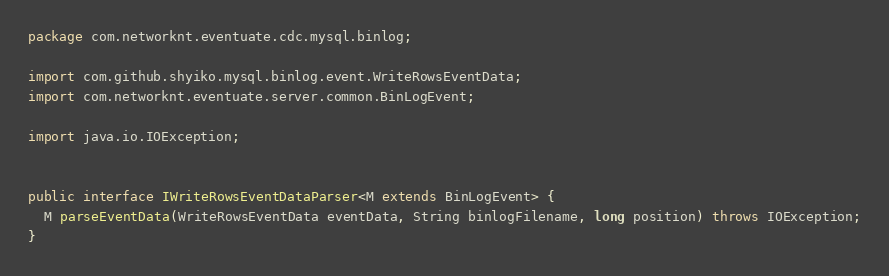<code> <loc_0><loc_0><loc_500><loc_500><_Java_>package com.networknt.eventuate.cdc.mysql.binlog;

import com.github.shyiko.mysql.binlog.event.WriteRowsEventData;
import com.networknt.eventuate.server.common.BinLogEvent;

import java.io.IOException;


public interface IWriteRowsEventDataParser<M extends BinLogEvent> {
  M parseEventData(WriteRowsEventData eventData, String binlogFilename, long position) throws IOException;
}
</code> 